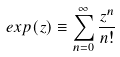<formula> <loc_0><loc_0><loc_500><loc_500>e x p ( z ) \equiv \sum _ { n = 0 } ^ { \infty } \frac { z ^ { n } } { n ! }</formula> 